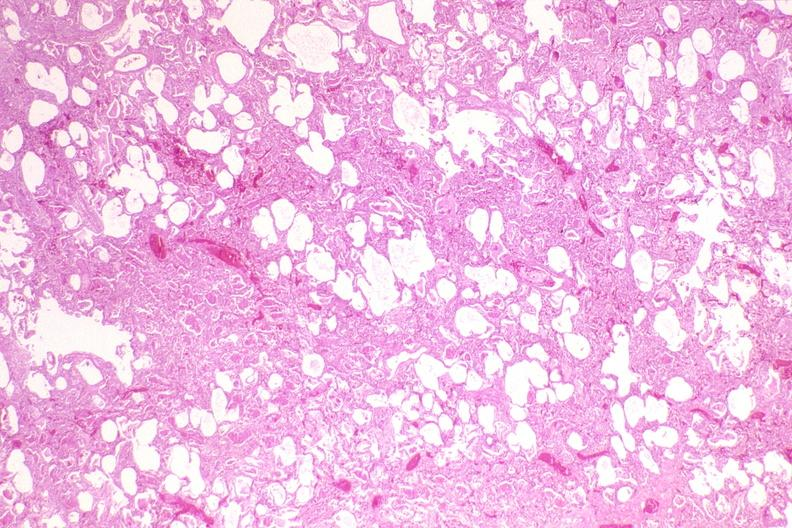s respiratory present?
Answer the question using a single word or phrase. Yes 